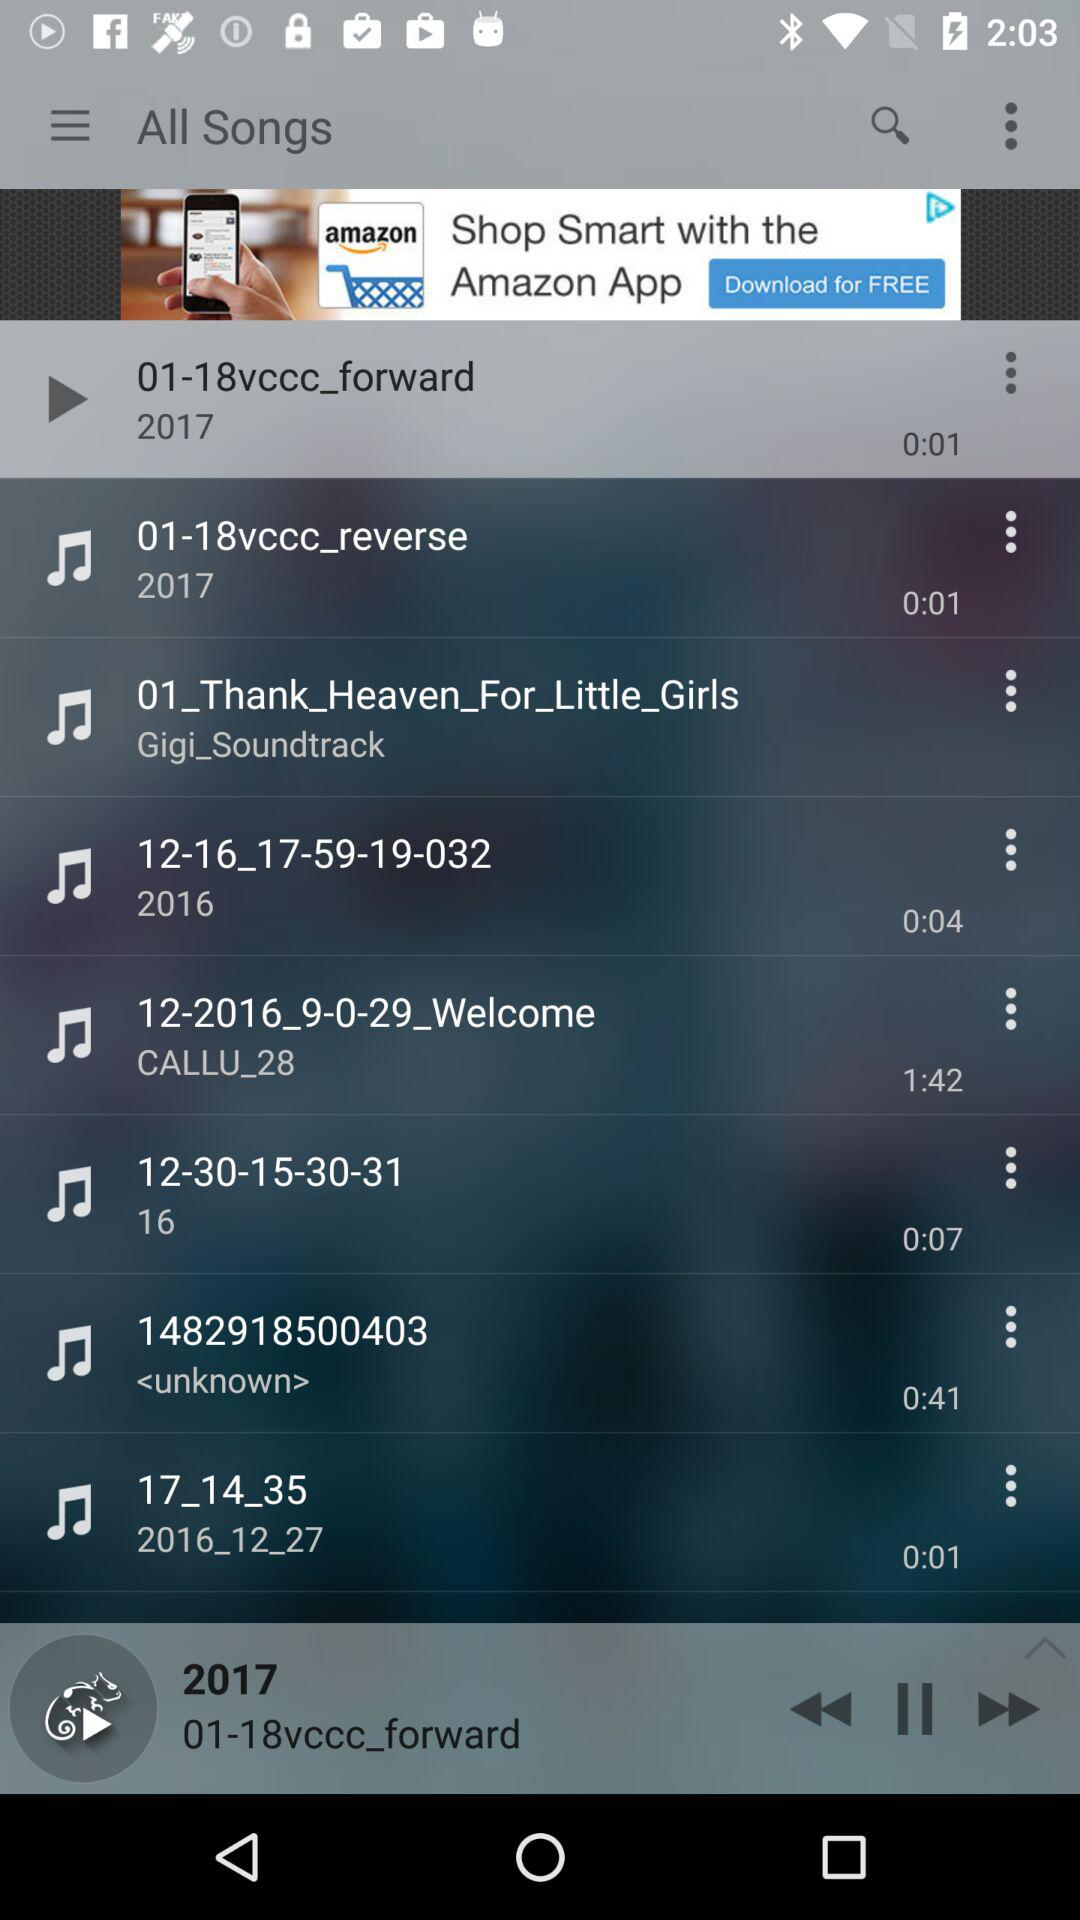Which audio has a length of 1:42? The audio has a length of 1:42 and is called 12-2016_9-0-29_Welcome. 